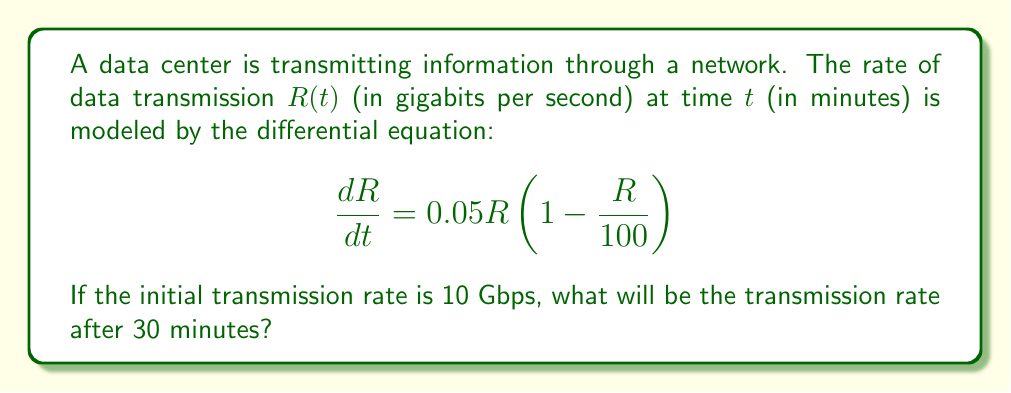Provide a solution to this math problem. To solve this problem, we need to follow these steps:

1) Recognize the differential equation as a logistic growth model:
   $$\frac{dR}{dt} = kR(1 - \frac{R}{M})$$
   where $k = 0.05$ and $M = 100$ (the maximum transmission rate).

2) The solution to this logistic equation is:
   $$R(t) = \frac{M}{1 + (\frac{M}{R_0} - 1)e^{-kt}}$$
   where $R_0$ is the initial rate.

3) Substitute the known values:
   $M = 100$, $k = 0.05$, $R_0 = 10$, and $t = 30$

4) Calculate:
   $$R(30) = \frac{100}{1 + (\frac{100}{10} - 1)e^{-0.05(30)}}$$

5) Simplify:
   $$R(30) = \frac{100}{1 + 9e^{-1.5}}$$

6) Evaluate:
   $$R(30) \approx 52.76$$

Therefore, after 30 minutes, the transmission rate will be approximately 52.76 Gbps.
Answer: 52.76 Gbps 